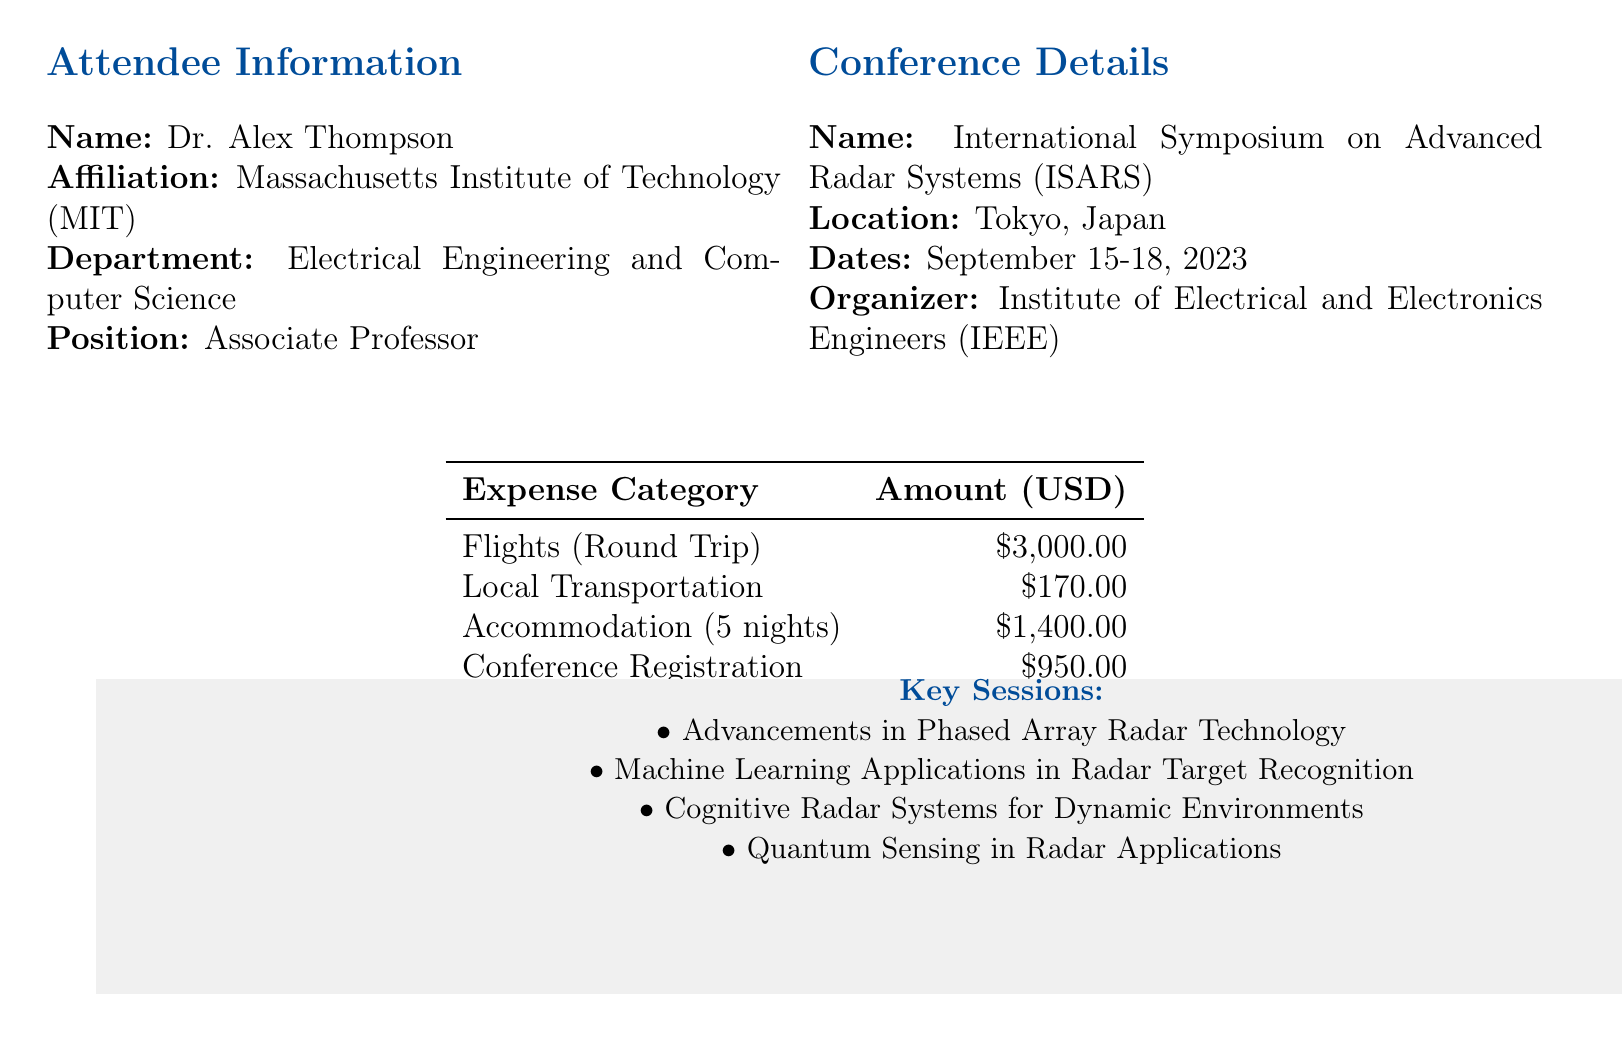What is the name of the conference? The name of the conference is provided under conference details.
Answer: International Symposium on Advanced Radar Systems (ISARS) Who is the attendee? The attendee's name is listed in the attendee information section.
Answer: Dr. Alex Thompson What is the total cost of accommodation? The total accommodation cost is mentioned in the expense table, calculated as the nightly rate multiplied by the number of nights.
Answer: 1400.00 How much did the flights cost? The total cost for flights is the sum of the outbound and return flight costs.
Answer: 3000.00 What is the registration fee type? The registration type is detailed in the conference fees section.
Answer: IEEE Member Early Bird How many nights did the attendee stay at the hotel? The number of nights is specified in the accommodation expenses section.
Answer: 5 What is the cost for local transportation? The local transportation cost totals the airport transfers and public transport together as per the expense breakdown.
Answer: 170.00 What is one of the keynote speaker's topics? The topics are listed for each keynote speaker in the document.
Answer: Next-Generation Satellite-based Radar Systems for Earth Observation How many days of meals are covered? The number of days for meal coverage is indicated in the meal expenses section.
Answer: 6 What is the total amount of additional expenses? Additional expenses consist of visa application, travel insurance, and internet access, which together form the total.
Answer: 175.00 